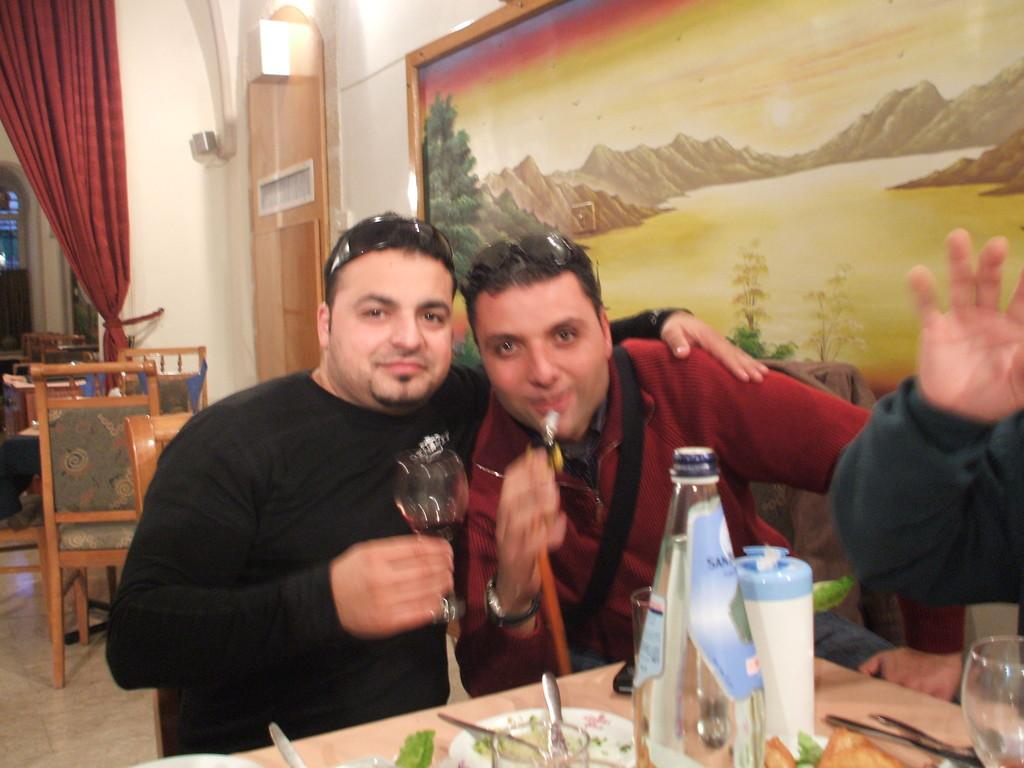How many people are in the image? There are two guys in the image. What are the two guys doing in the image? The two guys are posing for a picture. What can be seen in the background of the image? There is a painting on the wall in the background. What is present in the image besides the two guys? There is a table in the image, and food eatables are present on the table. Can you see any visible veins on the guys in the image? There is no information about the visibility of veins on the guys in the image. What type of roll is being used as a prop in the image? There is no roll present in the image. 